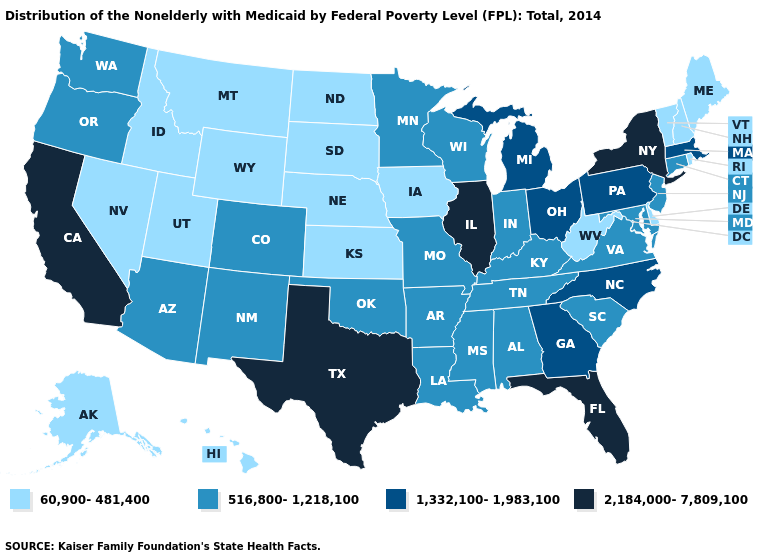What is the lowest value in states that border Texas?
Quick response, please. 516,800-1,218,100. What is the lowest value in states that border Illinois?
Be succinct. 60,900-481,400. Which states have the highest value in the USA?
Keep it brief. California, Florida, Illinois, New York, Texas. Name the states that have a value in the range 60,900-481,400?
Answer briefly. Alaska, Delaware, Hawaii, Idaho, Iowa, Kansas, Maine, Montana, Nebraska, Nevada, New Hampshire, North Dakota, Rhode Island, South Dakota, Utah, Vermont, West Virginia, Wyoming. What is the highest value in the USA?
Concise answer only. 2,184,000-7,809,100. What is the lowest value in the USA?
Quick response, please. 60,900-481,400. What is the value of Nevada?
Be succinct. 60,900-481,400. What is the value of Arizona?
Write a very short answer. 516,800-1,218,100. Name the states that have a value in the range 1,332,100-1,983,100?
Quick response, please. Georgia, Massachusetts, Michigan, North Carolina, Ohio, Pennsylvania. Among the states that border Kansas , which have the highest value?
Give a very brief answer. Colorado, Missouri, Oklahoma. What is the lowest value in the USA?
Give a very brief answer. 60,900-481,400. Name the states that have a value in the range 1,332,100-1,983,100?
Quick response, please. Georgia, Massachusetts, Michigan, North Carolina, Ohio, Pennsylvania. What is the value of South Dakota?
Write a very short answer. 60,900-481,400. What is the value of Nevada?
Give a very brief answer. 60,900-481,400. What is the highest value in states that border Wisconsin?
Write a very short answer. 2,184,000-7,809,100. 